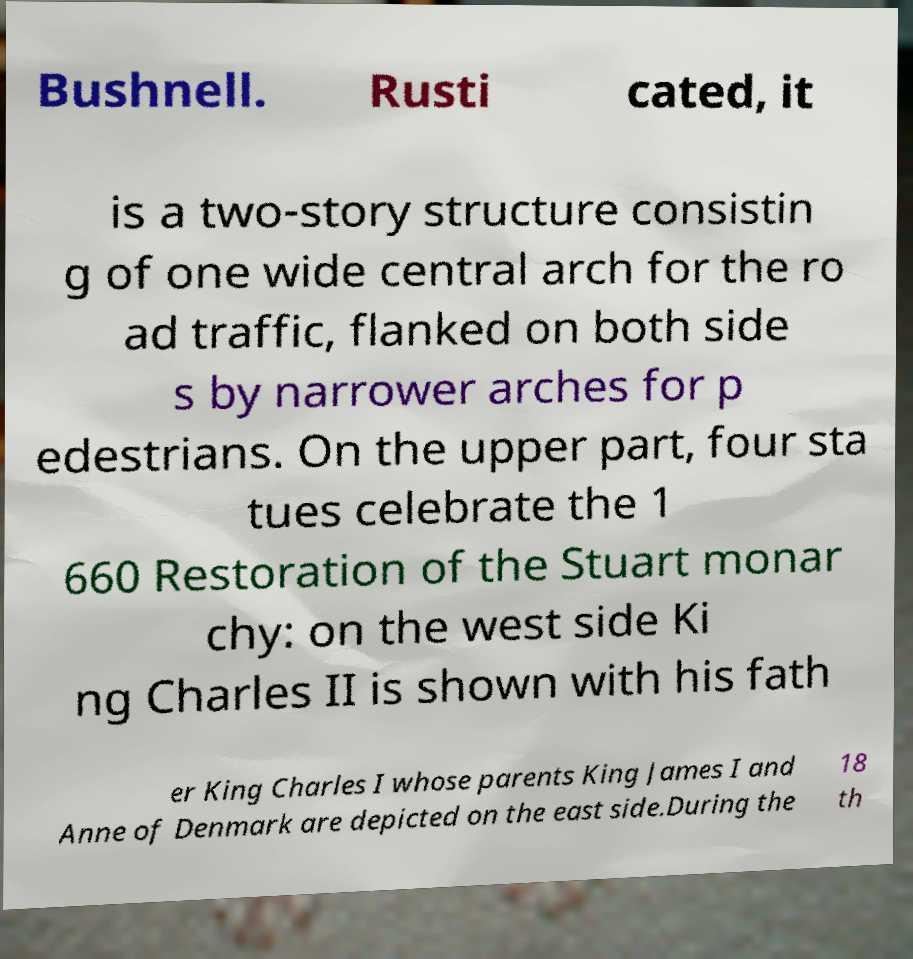What messages or text are displayed in this image? I need them in a readable, typed format. Bushnell. Rusti cated, it is a two-story structure consistin g of one wide central arch for the ro ad traffic, flanked on both side s by narrower arches for p edestrians. On the upper part, four sta tues celebrate the 1 660 Restoration of the Stuart monar chy: on the west side Ki ng Charles II is shown with his fath er King Charles I whose parents King James I and Anne of Denmark are depicted on the east side.During the 18 th 